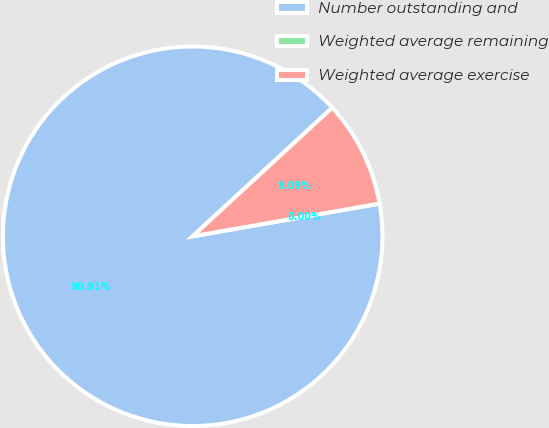Convert chart. <chart><loc_0><loc_0><loc_500><loc_500><pie_chart><fcel>Number outstanding and<fcel>Weighted average remaining<fcel>Weighted average exercise<nl><fcel>90.91%<fcel>0.0%<fcel>9.09%<nl></chart> 